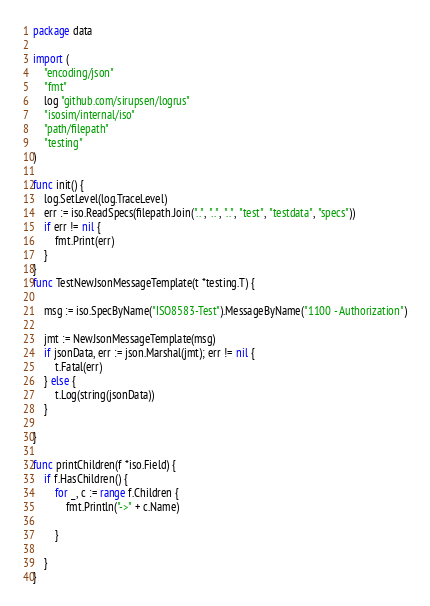Convert code to text. <code><loc_0><loc_0><loc_500><loc_500><_Go_>package data

import (
	"encoding/json"
	"fmt"
	log "github.com/sirupsen/logrus"
	"isosim/internal/iso"
	"path/filepath"
	"testing"
)

func init() {
	log.SetLevel(log.TraceLevel)
	err := iso.ReadSpecs(filepath.Join("..", "..", "..", "test", "testdata", "specs"))
	if err != nil {
		fmt.Print(err)
	}
}
func TestNewJsonMessageTemplate(t *testing.T) {

	msg := iso.SpecByName("ISO8583-Test").MessageByName("1100 - Authorization")

	jmt := NewJsonMessageTemplate(msg)
	if jsonData, err := json.Marshal(jmt); err != nil {
		t.Fatal(err)
	} else {
		t.Log(string(jsonData))
	}

}

func printChildren(f *iso.Field) {
	if f.HasChildren() {
		for _, c := range f.Children {
			fmt.Println("->" + c.Name)

		}

	}
}
</code> 